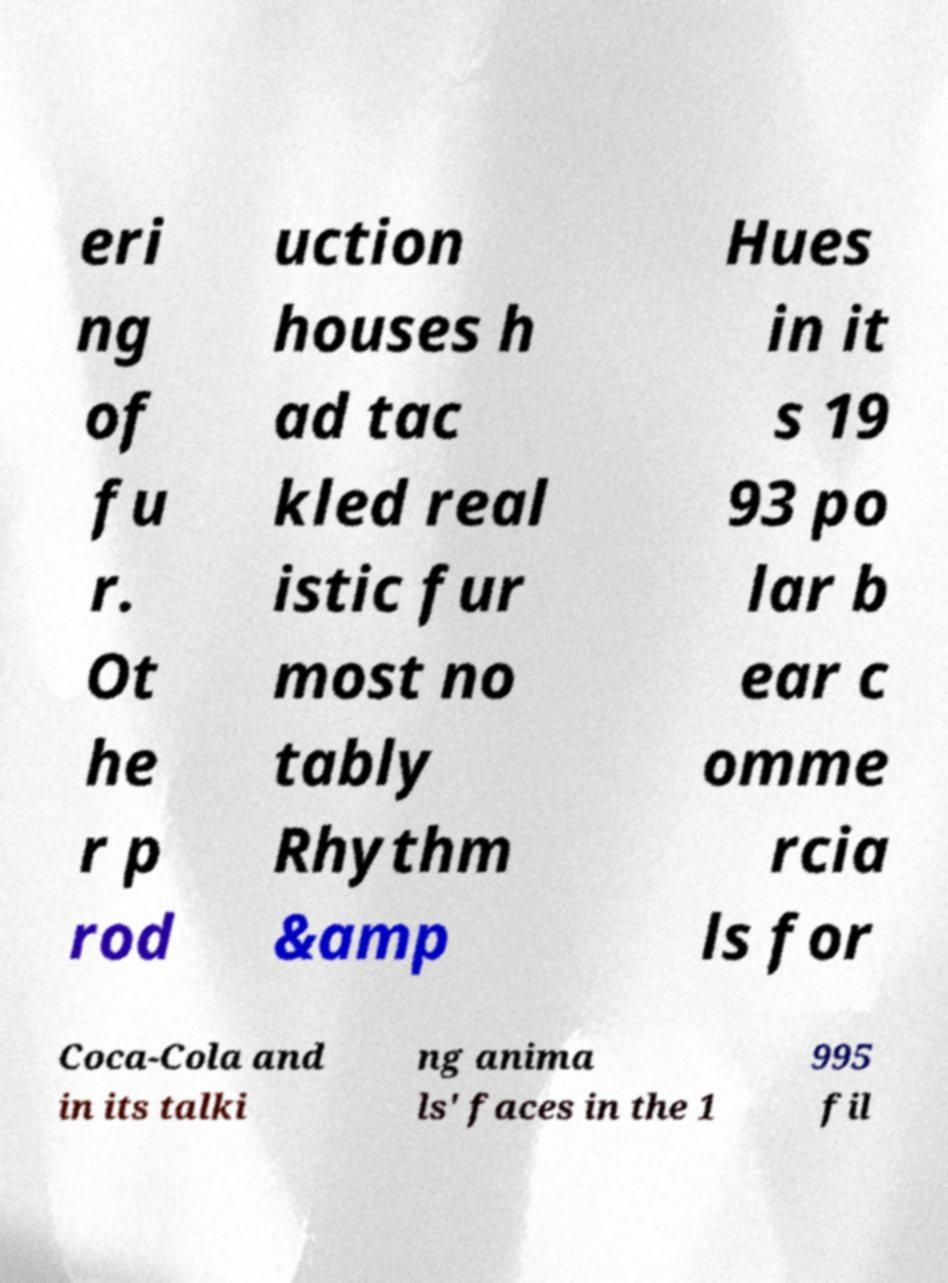Could you assist in decoding the text presented in this image and type it out clearly? eri ng of fu r. Ot he r p rod uction houses h ad tac kled real istic fur most no tably Rhythm &amp Hues in it s 19 93 po lar b ear c omme rcia ls for Coca-Cola and in its talki ng anima ls' faces in the 1 995 fil 